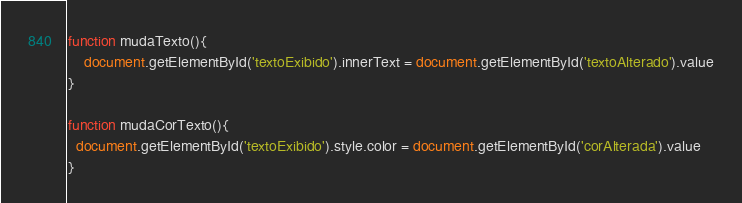Convert code to text. <code><loc_0><loc_0><loc_500><loc_500><_JavaScript_>function mudaTexto(){
    document.getElementById('textoExibido').innerText = document.getElementById('textoAlterado').value
}

function mudaCorTexto(){
  document.getElementById('textoExibido').style.color = document.getElementById('corAlterada').value
}
</code> 